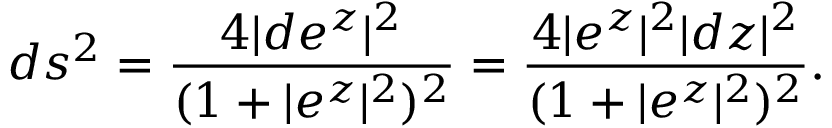<formula> <loc_0><loc_0><loc_500><loc_500>d s ^ { 2 } = \frac { 4 | d e ^ { z } | ^ { 2 } } { ( 1 + | e ^ { z } | ^ { 2 } ) ^ { 2 } } = \frac { 4 | e ^ { z } | ^ { 2 } | d z | ^ { 2 } } { ( 1 + | e ^ { z } | ^ { 2 } ) ^ { 2 } } .</formula> 